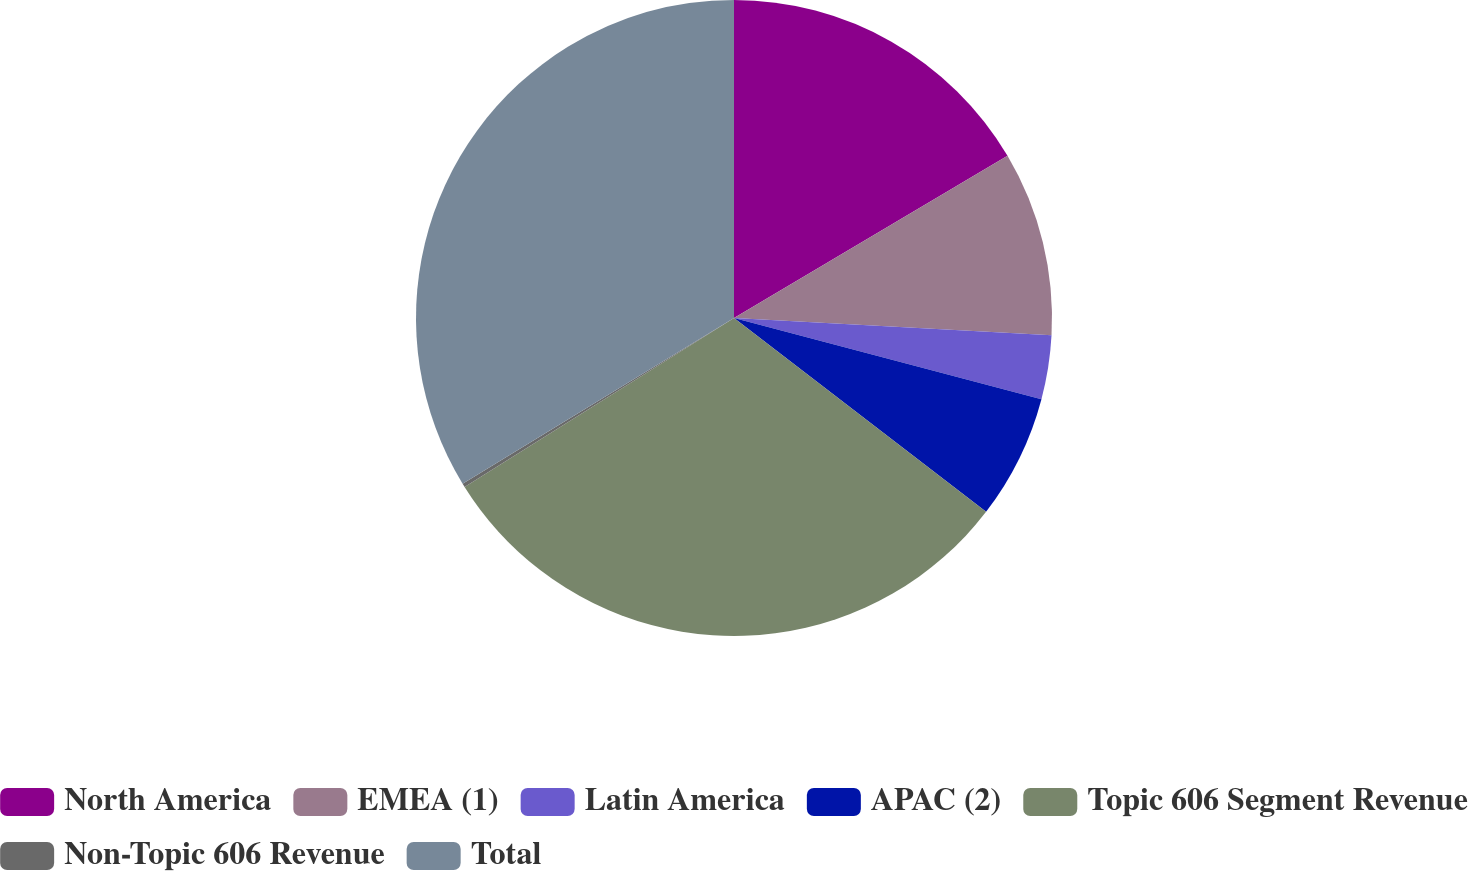Convert chart. <chart><loc_0><loc_0><loc_500><loc_500><pie_chart><fcel>North America<fcel>EMEA (1)<fcel>Latin America<fcel>APAC (2)<fcel>Topic 606 Segment Revenue<fcel>Non-Topic 606 Revenue<fcel>Total<nl><fcel>16.48%<fcel>9.38%<fcel>3.25%<fcel>6.32%<fcel>30.65%<fcel>0.19%<fcel>33.72%<nl></chart> 